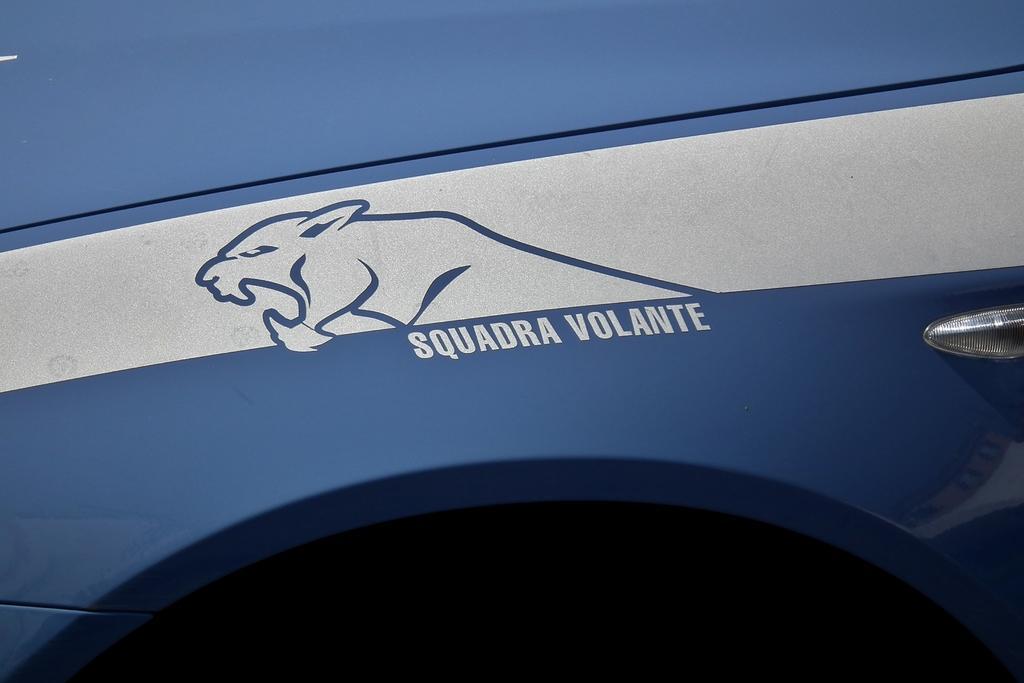Can you describe this image briefly? It is the body of a vehicle in blue color, there is a drawing of a jaguar in it. 